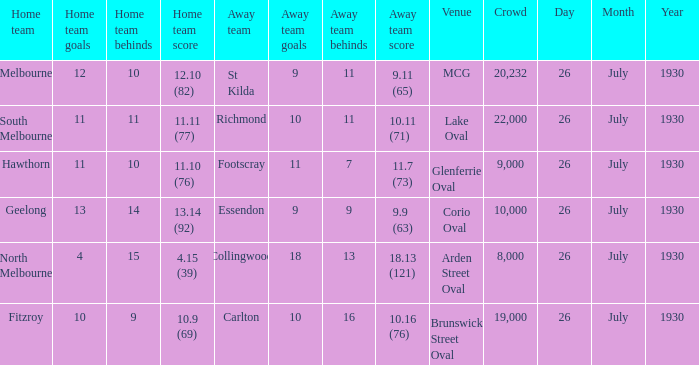Where did Geelong play a home game? Corio Oval. Parse the full table. {'header': ['Home team', 'Home team goals', 'Home team behinds', 'Home team score', 'Away team', 'Away team goals', 'Away team behinds', 'Away team score', 'Venue', 'Crowd', 'Day', 'Month', 'Year'], 'rows': [['Melbourne', '12', '10', '12.10 (82)', 'St Kilda', '9', '11', '9.11 (65)', 'MCG', '20,232', '26', 'July', '1930'], ['South Melbourne', '11', '11', '11.11 (77)', 'Richmond', '10', '11', '10.11 (71)', 'Lake Oval', '22,000', '26', 'July', '1930'], ['Hawthorn', '11', '10', '11.10 (76)', 'Footscray', '11', '7', '11.7 (73)', 'Glenferrie Oval', '9,000', '26', 'July', '1930'], ['Geelong', '13', '14', '13.14 (92)', 'Essendon', '9', '9', '9.9 (63)', 'Corio Oval', '10,000', '26', 'July', '1930'], ['North Melbourne', '4', '15', '4.15 (39)', 'Collingwood', '18', '13', '18.13 (121)', 'Arden Street Oval', '8,000', '26', 'July', '1930'], ['Fitzroy', '10', '9', '10.9 (69)', 'Carlton', '10', '16', '10.16 (76)', 'Brunswick Street Oval', '19,000', '26', 'July', '1930']]} 